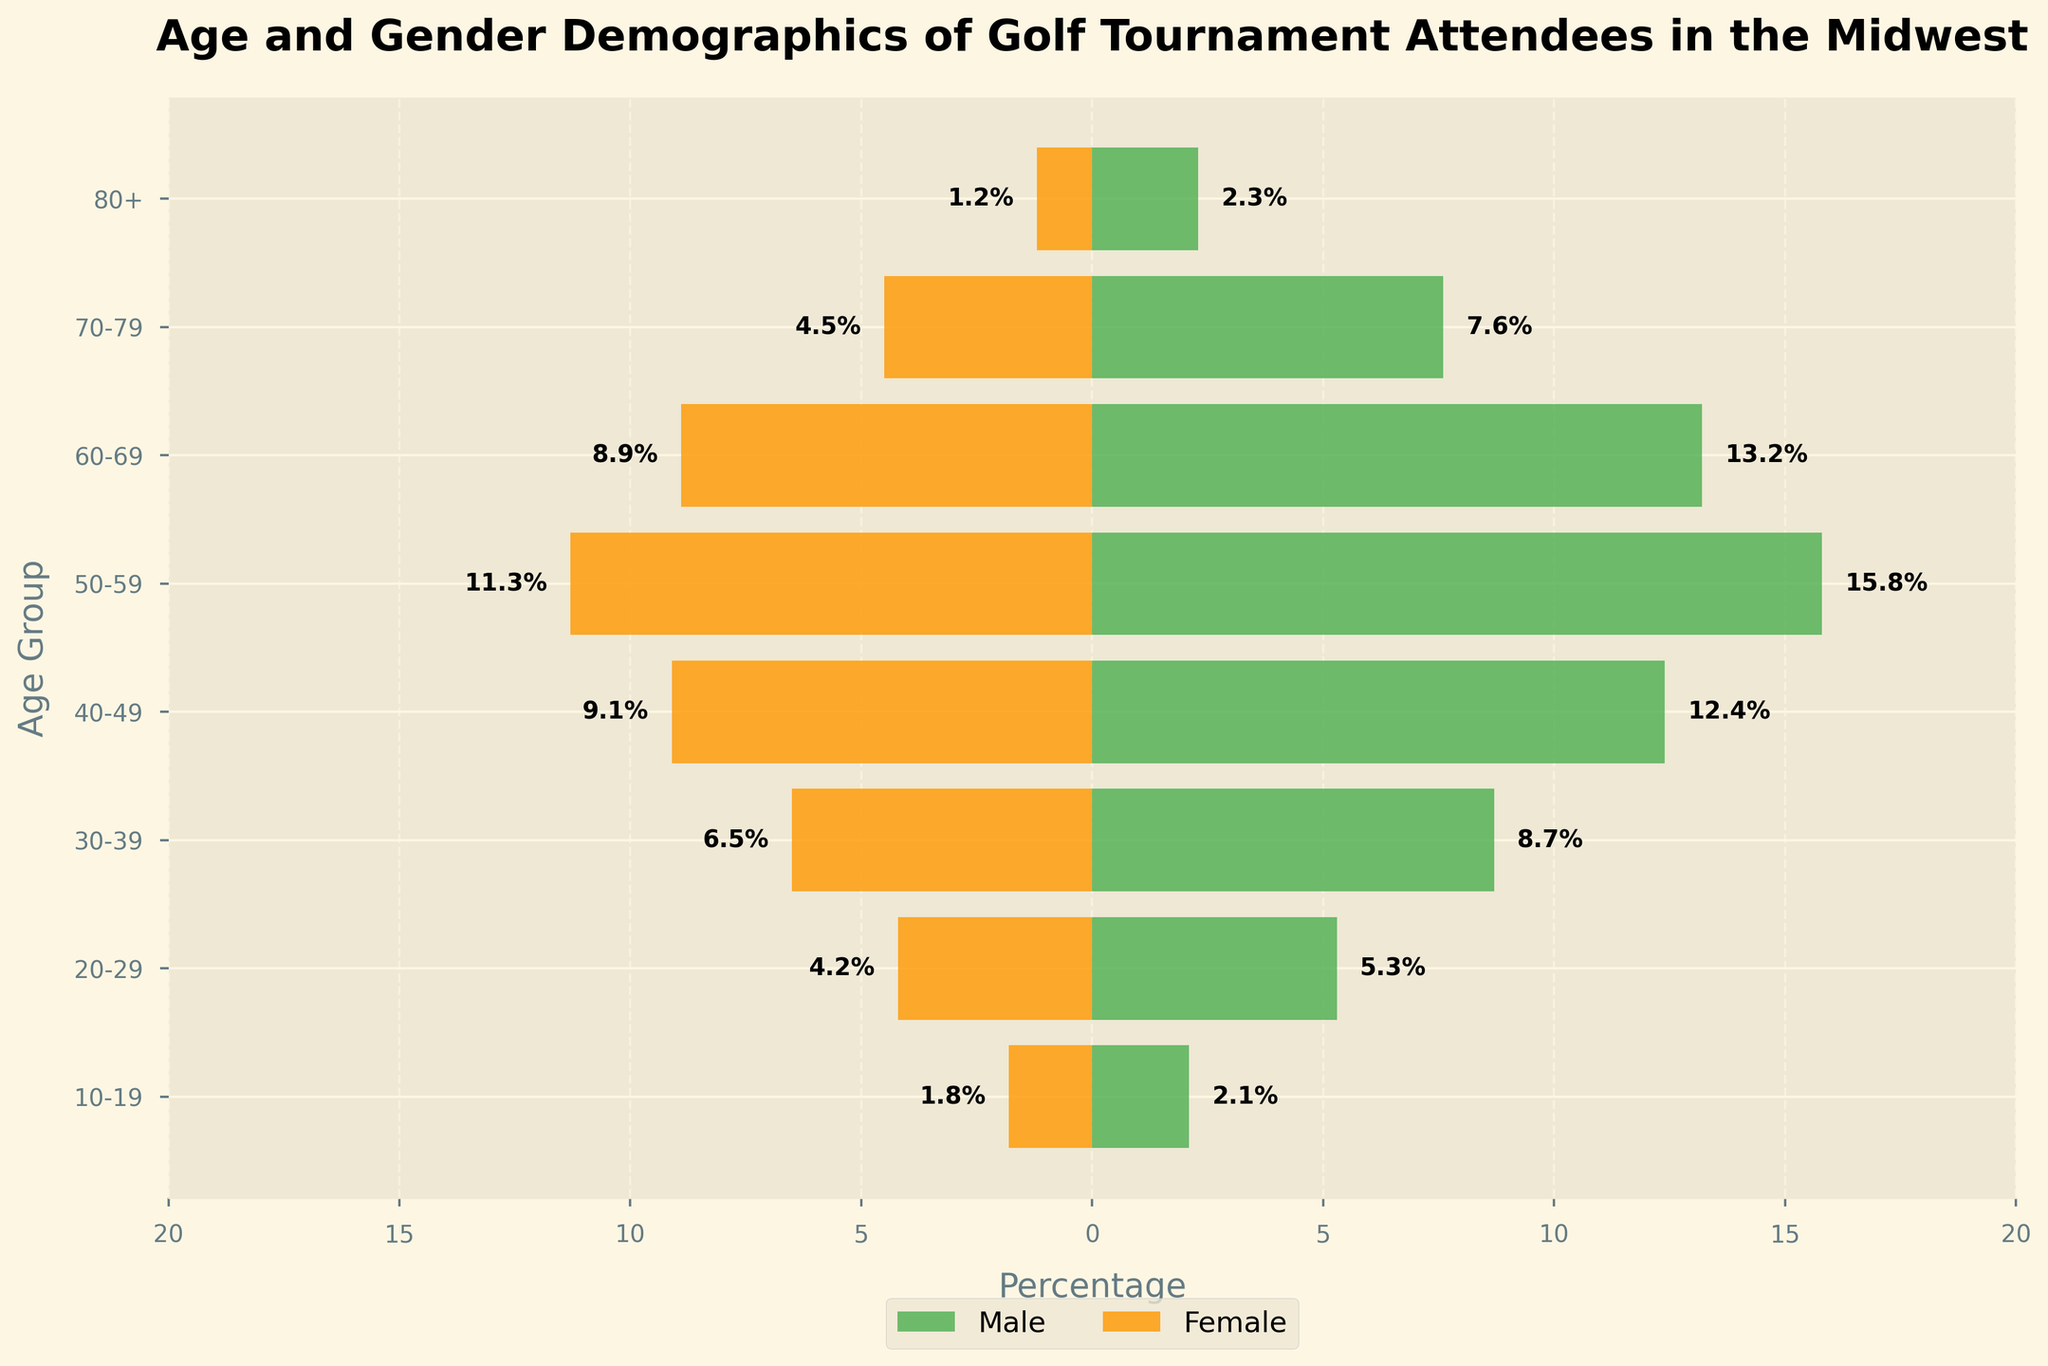What is the title of the figure? The title of the figure is the text at the top of the chart. It reads, "Age and Gender Demographics of Golf Tournament Attendees in the Midwest".
Answer: Age and Gender Demographics of Golf Tournament Attendees in the Midwest Which age group has the highest percentage of male attendees? We look at the length of the green bars for each age group. The longest green bar is for the 50-59 age group.
Answer: 50-59 What is the percentage of female attendees in the 30-39 age group? We find the orange bar corresponding to the 30-39 age group and check the label on its negative end, which reads 6.5%.
Answer: 6.5% How does the percentage of male attendees in the 20-29 age group compare to the percentage of female attendees in the same age group? Compare the green and orange bars for the 20-29 age group. The green bar for males is labeled 5.3%, and the orange bar for females is labeled 4.2%.
Answer: 5.3% for males, 4.2% for females What is the combined percentage of male and female attendees in the 60-69 age group? Add the percentages from both bars for the 60-69 age group: 13.2% (male) + 8.9% (female) = 22.1%.
Answer: 22.1% What is the largest age group for female attendees, and what is its percentage? Look for the longest orange bar. The longest bar is in the 50-59 age group, with a percentage of 11.3%.
Answer: 50-59, 11.3% Which age group has the most significant difference in attendance percentage between males and females, and what is the difference? For each age group, calculate the difference between male and female percentages, then identify the largest difference. The 50-59 age group has a difference: 15.8% (male) - 11.3% (female) = 4.5%.
Answer: 50-59, 4.5% What is the average percentage of male attendees across all age groups? Sum the male percentages and divide by the number of age groups: (2.1 + 5.3 + 8.7 + 12.4 + 15.8 + 13.2 + 7.6 + 2.3) / 8 = 67.4 / 8 = 8.425%.
Answer: 8.425% How does the percentage of attendees in the 70-79 age group compare to those in the 80+ age group for both genders? To compare, check the bars for both genders in the 70-79 and 80+ age groups. For males, 7.6% (70-79) vs. 2.3% (80+). For females, 4.5% (70-79) vs. 1.2% (80+).
Answer: 7.6% vs. 2.3% (males), 4.5% vs. 1.2% (females) 